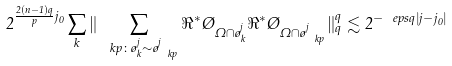Convert formula to latex. <formula><loc_0><loc_0><loc_500><loc_500>2 ^ { \frac { 2 ( n - 1 ) q } { p } j _ { 0 } } \sum _ { k } \| \sum _ { \ k p \colon \tau ^ { j } _ { k } \sim \tau ^ { j } _ { \ k p } } \Re ^ { * } \chi _ { \Omega \cap \tau ^ { j } _ { k } } \Re ^ { * } \chi _ { \Omega \cap \tau ^ { j } _ { \ k p } } \| _ { q } ^ { q } \lesssim 2 ^ { - \ e p s q | j - j _ { 0 } | }</formula> 